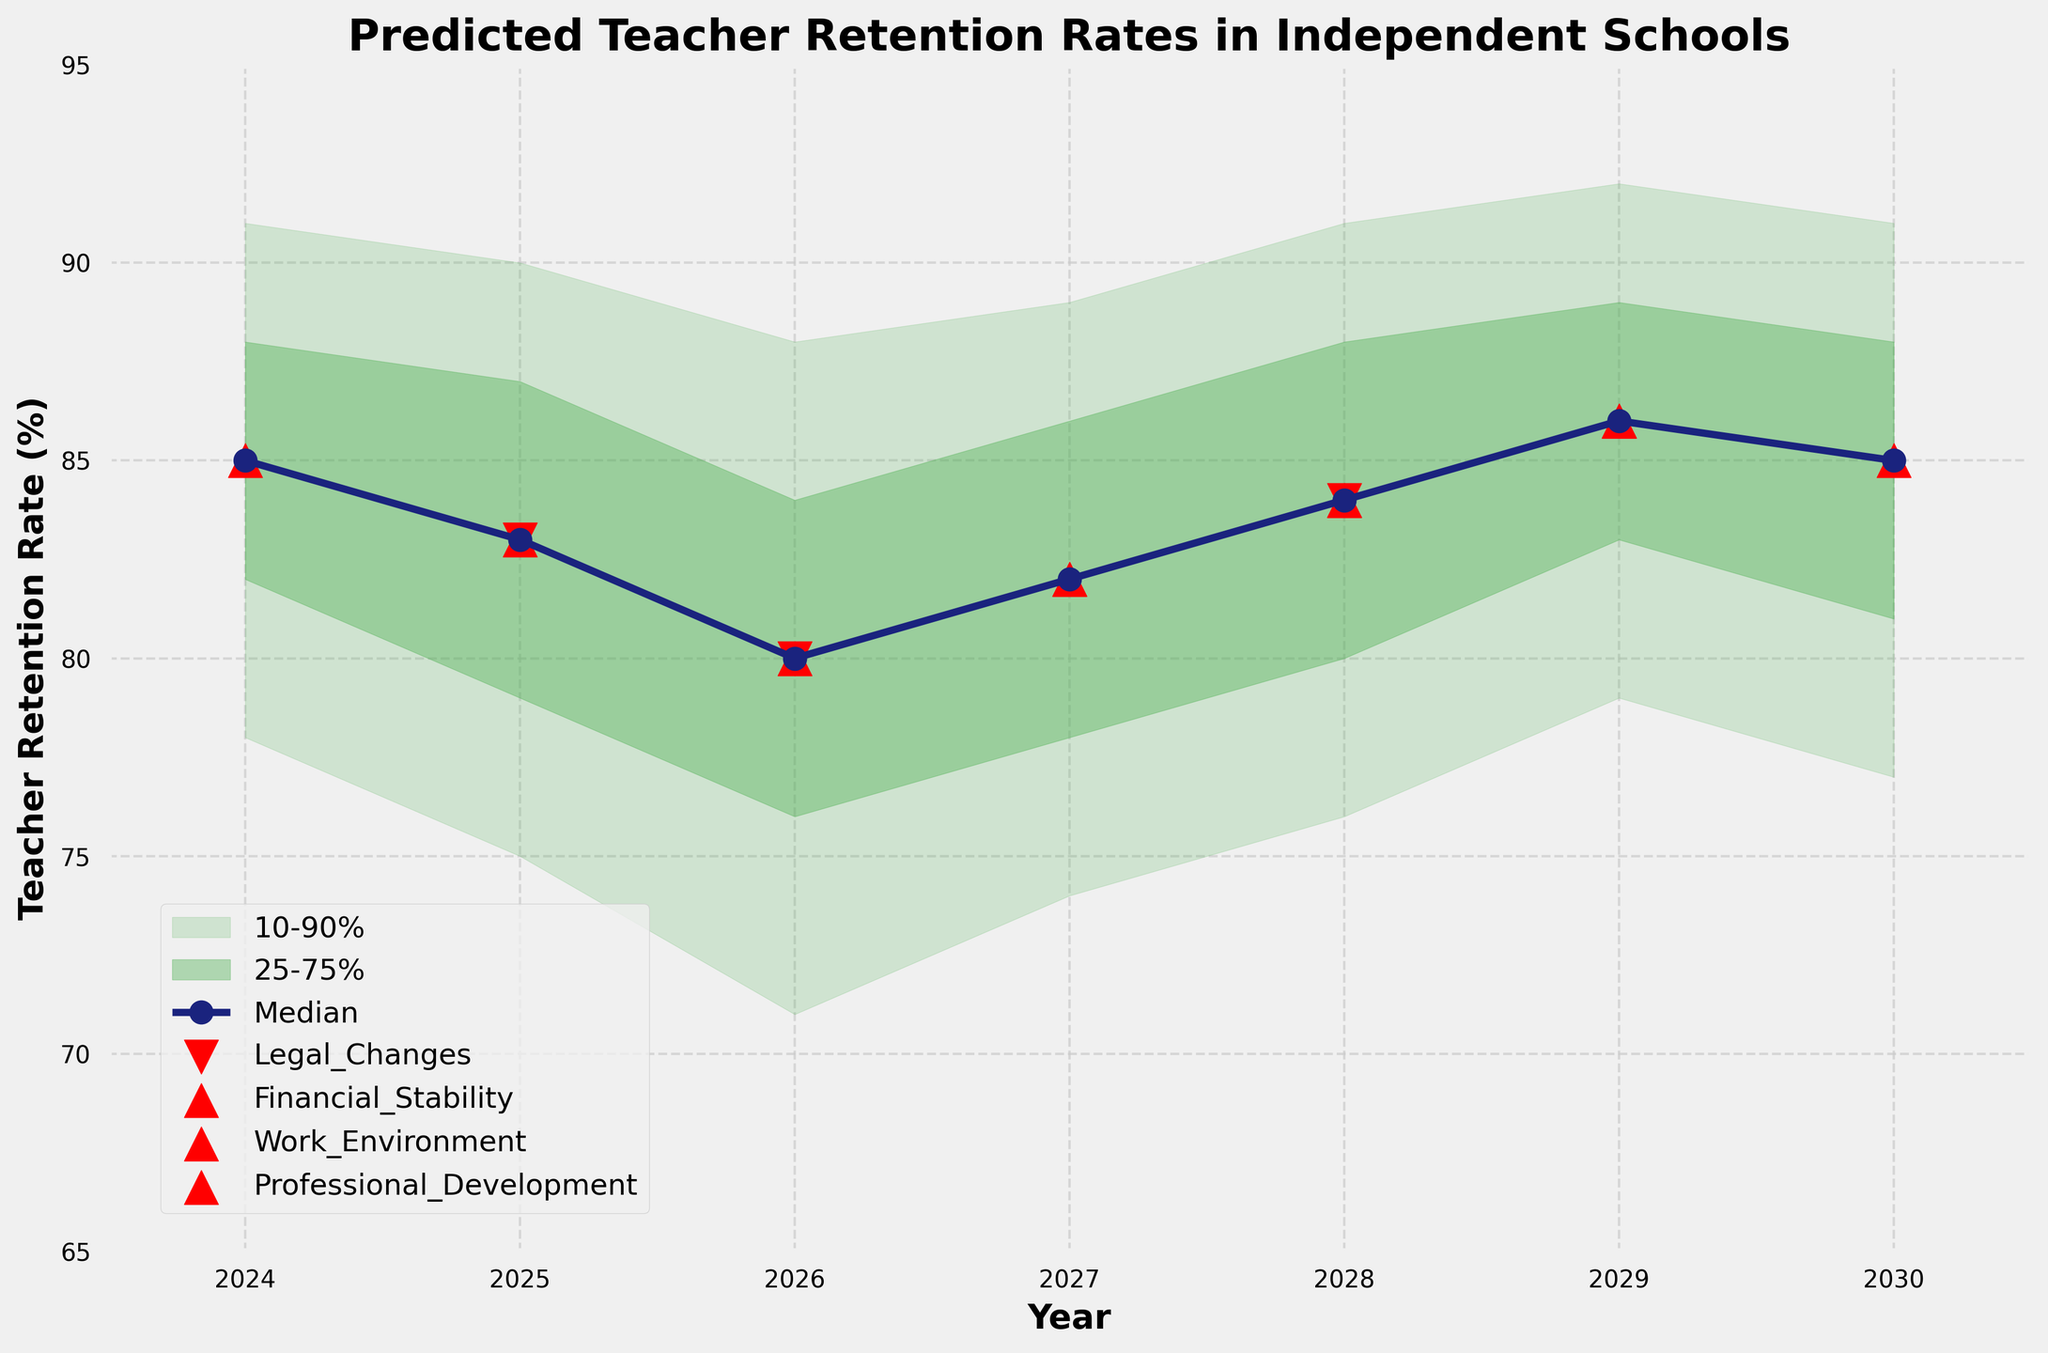What is the title of the figure? The title is displayed at the top of the figure and indicates the main subject of the chart.
Answer: Predicted Teacher Retention Rates in Independent Schools What is the highest predicted median teacher retention rate, and in which year does it occur? The highest median teacher retention rate is found by looking at the values of the median line. The highest value is 86, which occurs in 2029.
Answer: 86 in 2029 Which year has the lowest predicted median retention rate? To find the year with the lowest median retention rate, compare all median values on the plot. The lowest value is 80, which occurs in 2026.
Answer: 2026 In which year does a legal change positively influence teacher retention? A positive influence of a legal change is indicated by an upward red triangle. In 2028, a red triangle is seen at the median prediction.
Answer: 2028 Are there any years showing a negative influence from financial stability on teacher retention rates? Negative influences from financial stability are represented by downward red triangles. These are seen in 2026.
Answer: Yes, in 2026 What is the range between the 10th percentile and 90th percentile prediction for the year 2025? The range can be calculated by subtracting the 10th percentile value from the 90th percentile value for 2025. It’s 90 - 75 = 15.
Answer: 15 Compare the median predicted retention rates between 2024 and 2027. Which year has a higher median? By comparing the median values for 2024 and 2027, it's 85 in 2024 and 82 in 2027. 2024 has the higher median value.
Answer: 2024 How many years show a median retention rate above 84%? To find out the number of years above 84%, count the median values greater than 84% from the chart. Years 2024, 2028, 2029, and 2030 have medians above 84%. This gives us 4 years.
Answer: 4 What is the gap between the 25th and 75th percentile for the year 2027? The gap is the difference between the 75th and 25th percentile values for 2027. It’s 86 - 78 = 8.
Answer: 8 Among the influencing factors, which one recurrently marks positive changes toward teacher retention? By looking at the markers (upward red triangles) along the median line, professional development appears most frequently as a positive influence in 2025, 2027, 2029, and 2030.
Answer: Professional Development 